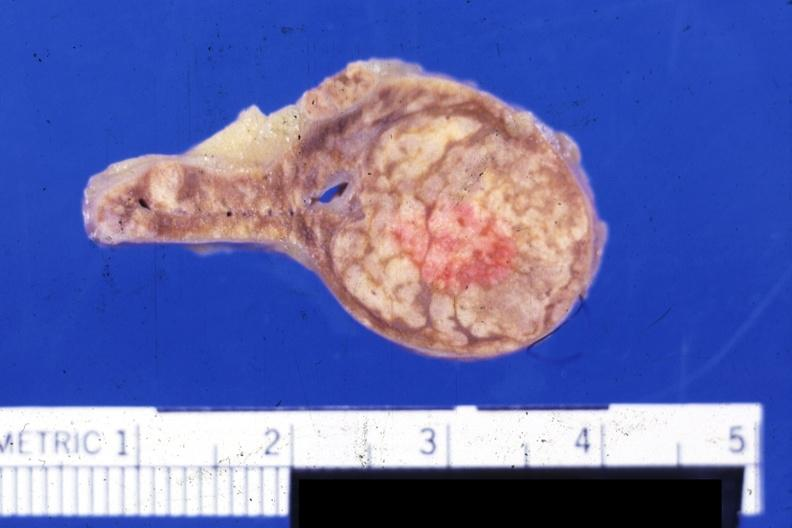what is present?
Answer the question using a single word or phrase. Endocrine 